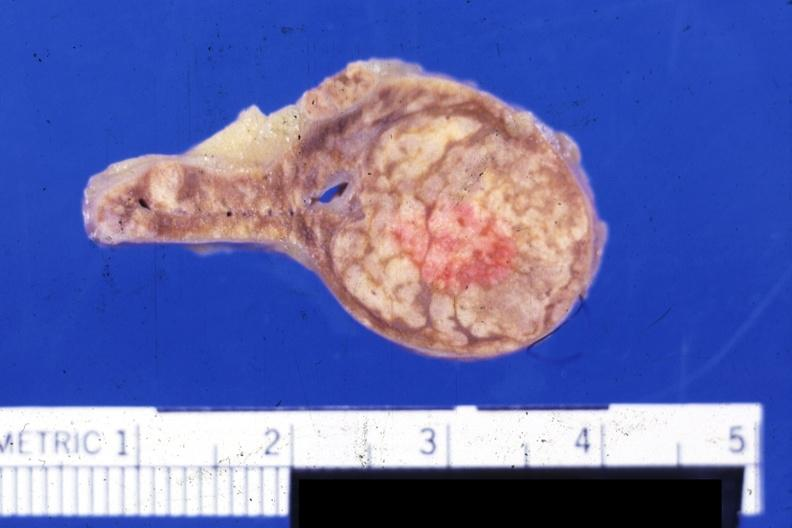what is present?
Answer the question using a single word or phrase. Endocrine 